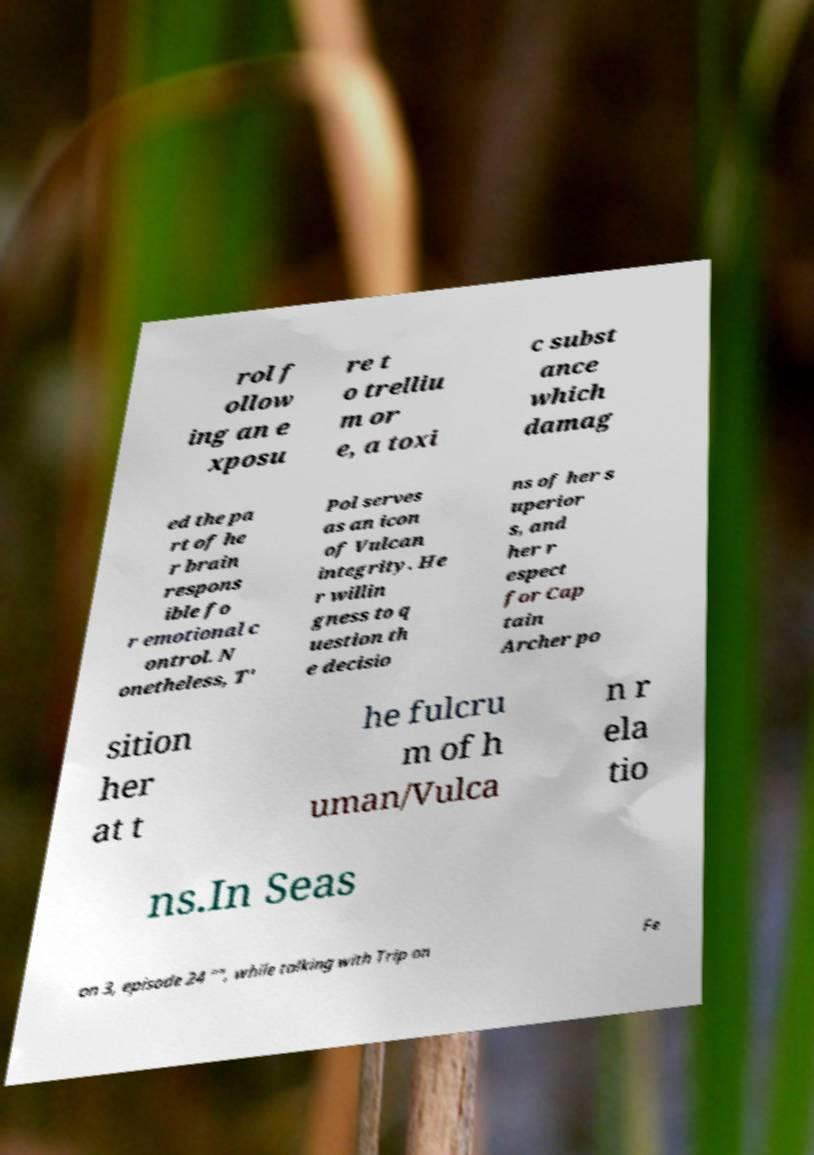Can you read and provide the text displayed in the image?This photo seems to have some interesting text. Can you extract and type it out for me? rol f ollow ing an e xposu re t o trelliu m or e, a toxi c subst ance which damag ed the pa rt of he r brain respons ible fo r emotional c ontrol. N onetheless, T' Pol serves as an icon of Vulcan integrity. He r willin gness to q uestion th e decisio ns of her s uperior s, and her r espect for Cap tain Archer po sition her at t he fulcru m of h uman/Vulca n r ela tio ns.In Seas on 3, episode 24 "", while talking with Trip on Fe 